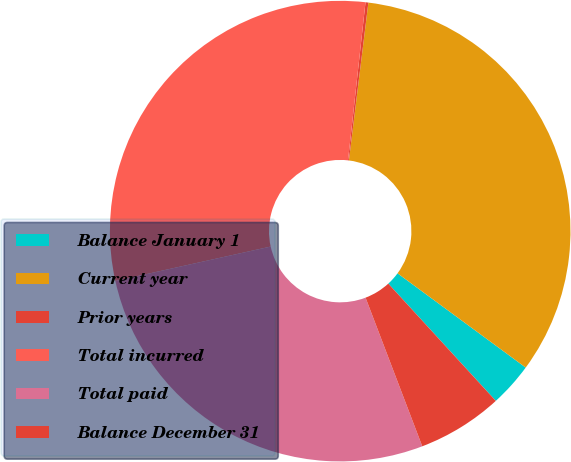Convert chart to OTSL. <chart><loc_0><loc_0><loc_500><loc_500><pie_chart><fcel>Balance January 1<fcel>Current year<fcel>Prior years<fcel>Total incurred<fcel>Total paid<fcel>Balance December 31<nl><fcel>3.1%<fcel>33.14%<fcel>0.2%<fcel>30.23%<fcel>27.33%<fcel>6.01%<nl></chart> 